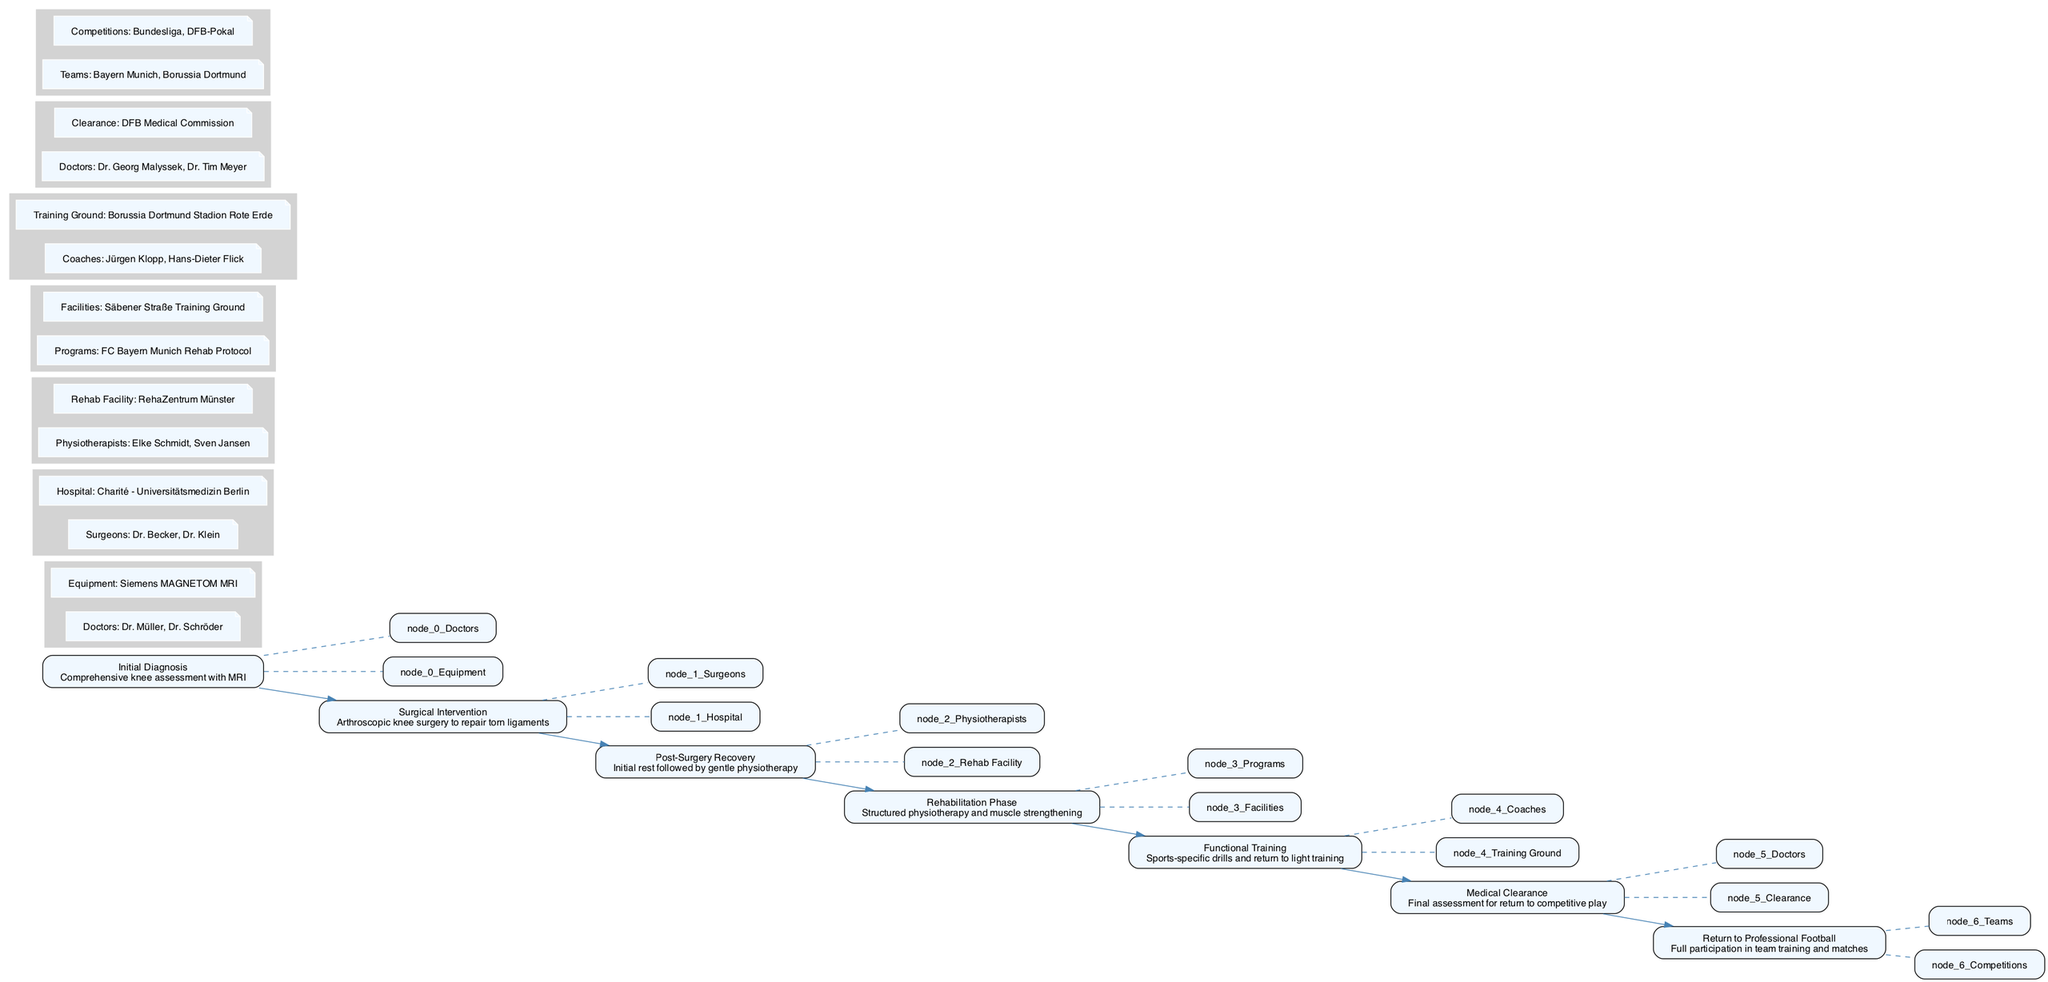What is the first step in the recovery process? The first step in the recovery process is "Initial Diagnosis," which involves a comprehensive knee assessment using MRI.
Answer: Initial Diagnosis How many phases are there in the recovery journey? There are six distinct phases in the recovery journey: Initial Diagnosis, Surgical Intervention, Post-Surgery Recovery, Rehabilitation Phase, Functional Training, and Medical Clearance.
Answer: Six Who performs the arthroscopic knee surgery? The surgeons performing the arthroscopic knee surgery are Dr. Becker and Dr. Klein.
Answer: Dr. Becker, Dr. Klein What is the focus of the Rehabilitation Phase? The focus of the Rehabilitation Phase is on structured physiotherapy and muscle strengthening.
Answer: Muscle strengthening Which facility is associated with the Post-Surgery Recovery? The Rehab Facility associated with Post-Surgery Recovery is RehaZentrum Münster.
Answer: RehaZentrum Münster What type of training is included before medical clearance? The training included before medical clearance is "sports-specific drills and return to light training".
Answer: Sports-specific drills Who gives the final clearance for returning to competitive play? The final clearance for returning to competitive play is given by the DFB Medical Commission, which includes Dr. Georg Malyssek and Dr. Tim Meyer.
Answer: DFB Medical Commission What procedure follows the Initial Diagnosis? The procedure that follows the Initial Diagnosis is Surgical Intervention, which consists of arthroscopic knee surgery.
Answer: Surgical Intervention Which teams can a player return to after completing their recovery? A player can return to teams like Bayern Munich and Borussia Dortmund after completing their recovery.
Answer: Bayern Munich, Borussia Dortmund 